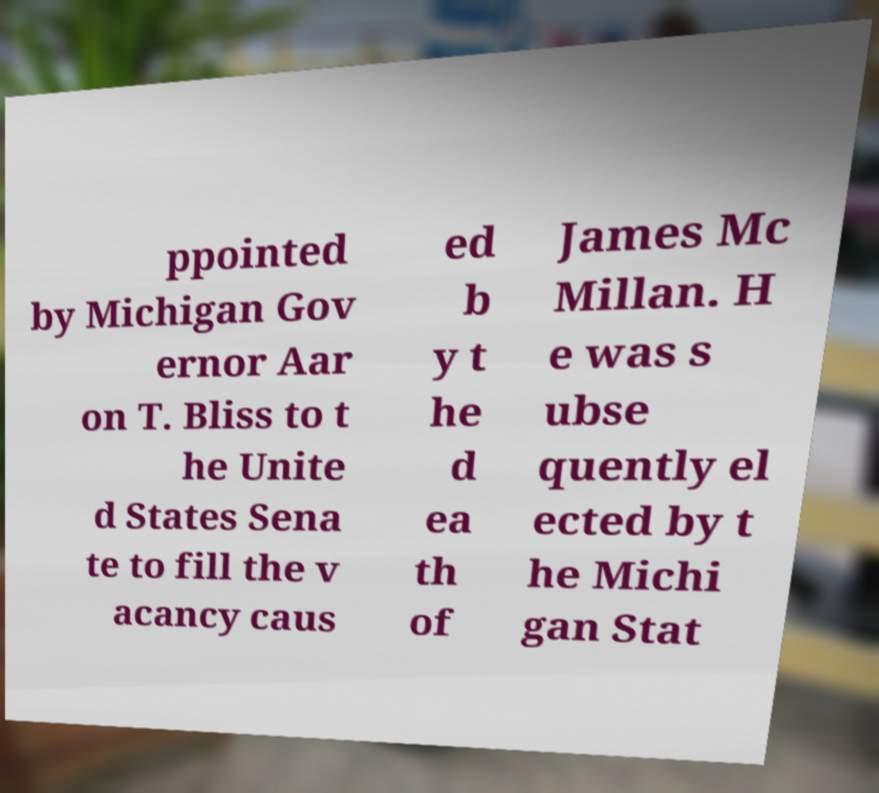Could you extract and type out the text from this image? ppointed by Michigan Gov ernor Aar on T. Bliss to t he Unite d States Sena te to fill the v acancy caus ed b y t he d ea th of James Mc Millan. H e was s ubse quently el ected by t he Michi gan Stat 